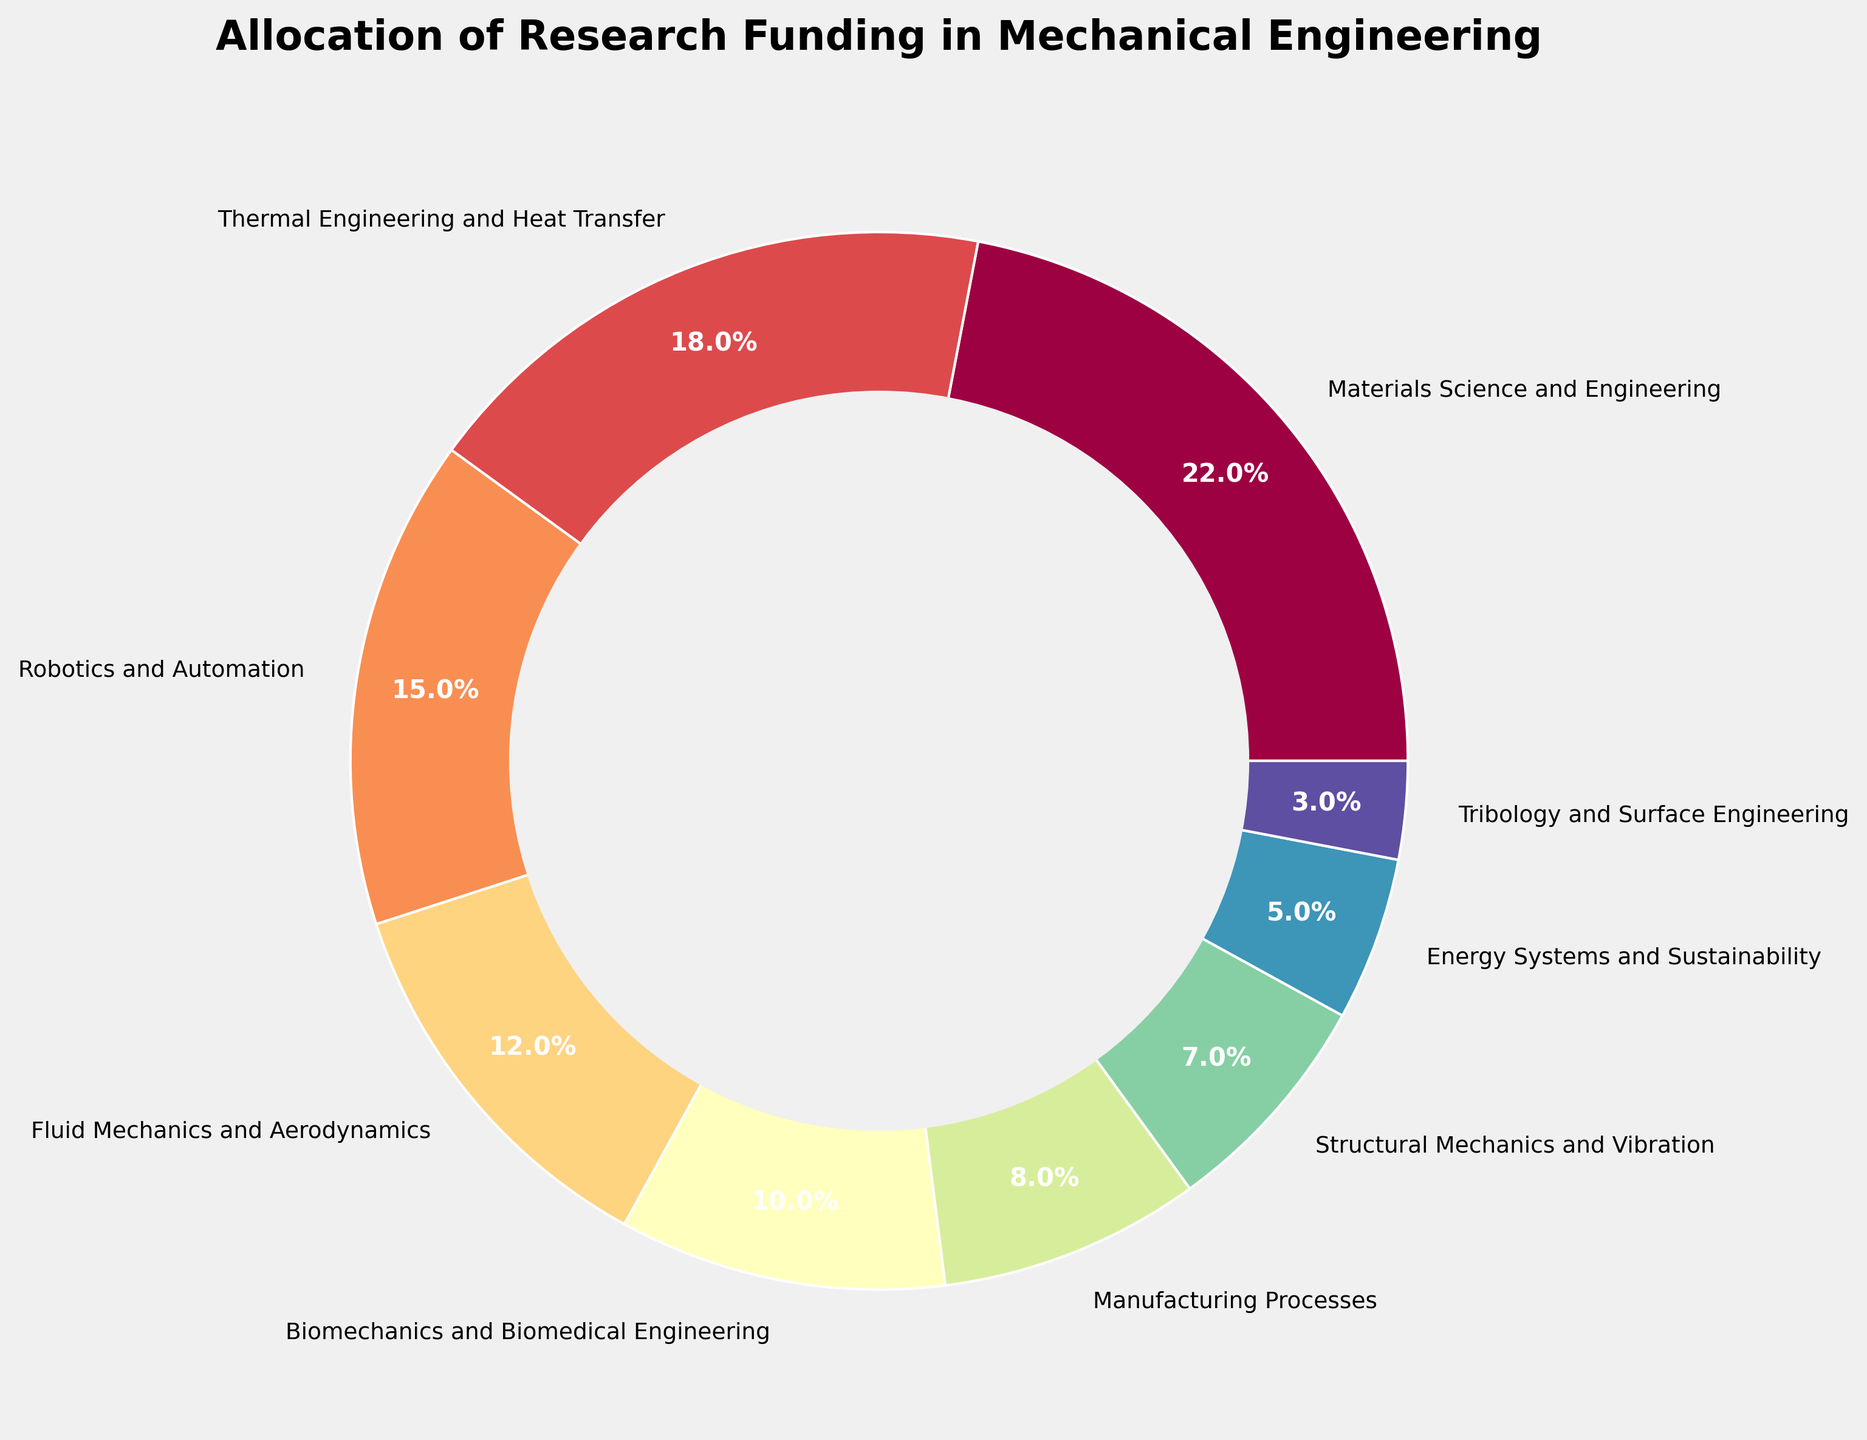Which branch has the highest funding percentage? By looking at the sizes of the pie chart segments, the segment for "Materials Science and Engineering" is the largest.
Answer: Materials Science and Engineering What is the difference in funding percentage between Fluid Mechanics and Aerodynamics and Thermal Engineering and Heat Transfer? The percentage for Fluid Mechanics and Aerodynamics is 12%, and for Thermal Engineering and Heat Transfer, it is 18%. Subtracting the former from the latter, 18% - 12% = 6%.
Answer: 6% Which branch has the smallest funding percentage, and what is that percentage? The smallest segment in the pie chart is for "Tribology and Surface Engineering."
Answer: Tribology and Surface Engineering, 3% Are there any branches with equal funding percentages? By examining each percentage value in the chart, it is evident that no two branches have the same funding percentage.
Answer: No What is the combined funding percentage for Biomechanics and Biomedical Engineering, and Structural Mechanics and Vibration? The percentage for Biomechanics and Biomedical Engineering is 10%, and for Structural Mechanics and Vibration, it is 7%. Adding them together, 10% + 7% = 17%.
Answer: 17% Which branch has more funding: Manufacturing Processes or Energy Systems and Sustainability? The percentage for Manufacturing Processes is 8%, while for Energy Systems and Sustainability, it is 5%. Comparing these two values, 8% is greater than 5%.
Answer: Manufacturing Processes What is the average funding percentage for all listed branches? Adding all the percentages: 22% (Materials Science and Engineering) + 18% (Thermal Engineering and Heat Transfer) + 15% (Robotics and Automation) + 12% (Fluid Mechanics and Aerodynamics) + 10% (Biomechanics and Biomedical Engineering) + 8% (Manufacturing Processes) + 7% (Structural Mechanics and Vibration) + 5% (Energy Systems and Sustainability) + 3% (Tribology and Surface Engineering) = 100%. Dividing by the number of branches, 100% / 9 = 11.11%.
Answer: 11.11% What is the combined funding percentage of Thermal Engineering and Heat Transfer, and Robotics and Automation? The percentage for Thermal Engineering and Heat Transfer is 18%, and for Robotics and Automation, it is 15%. Adding them together, 18% + 15% = 33%.
Answer: 33% Which two branches together make up more than a quarter of the total funding percentage? By examining the individual percentages, the two largest branches are "Materials Science and Engineering" (22%) and "Thermal Engineering and Heat Transfer" (18%). Adding them together, 22% + 18% = 40%, which is more than 25% of the total.
Answer: Materials Science and Engineering, Thermal Engineering and Heat Transfer 